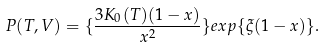<formula> <loc_0><loc_0><loc_500><loc_500>P ( T , V ) = \{ \frac { 3 K _ { 0 } ( T ) ( 1 - x ) } { x ^ { 2 } } \} e x p \{ \xi ( 1 - x ) \} .</formula> 